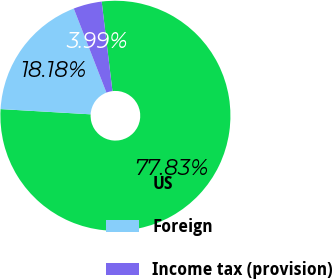Convert chart. <chart><loc_0><loc_0><loc_500><loc_500><pie_chart><fcel>US<fcel>Foreign<fcel>Income tax (provision)<nl><fcel>77.83%<fcel>18.18%<fcel>3.99%<nl></chart> 